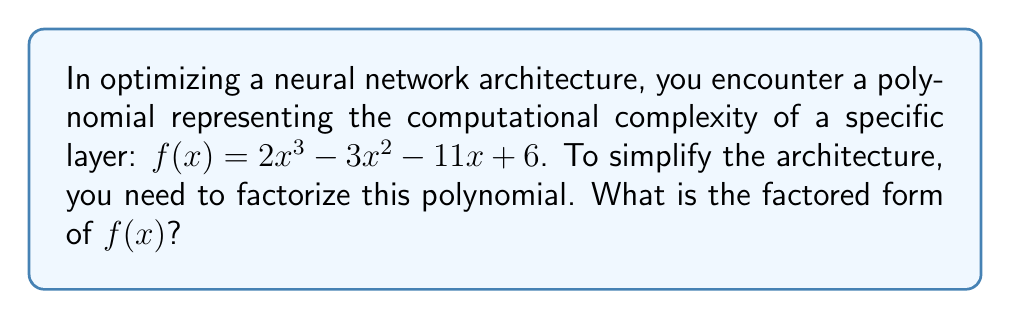Could you help me with this problem? To factorize this polynomial, we'll follow these steps:

1) First, let's check if there are any common factors. In this case, there are none.

2) Next, we'll use the rational root theorem to find potential roots. The potential rational roots are the factors of the constant term (6): ±1, ±2, ±3, ±6.

3) Let's test these potential roots:
   $f(1) = 2 - 3 - 11 + 6 = -6 \neq 0$
   $f(-1) = -2 - 3 + 11 + 6 = 12 \neq 0$
   $f(2) = 16 - 12 - 22 + 6 = -12 \neq 0$
   $f(-2) = -16 - 12 + 22 + 6 = 0$

4) We found that -2 is a root. So $(x+2)$ is a factor of $f(x)$.

5) We can divide $f(x)$ by $(x+2)$ to get the other factor:

   $$\frac{2x^3 - 3x^2 - 11x + 6}{x+2} = 2x^2 - 7x + 3$$

6) Now we need to factorize $2x^2 - 7x + 3$. Let's use the quadratic formula:
   
   $$x = \frac{7 \pm \sqrt{49 - 24}}{4} = \frac{7 \pm 5}{4}$$

7) This gives us two more roots: $x = 3$ and $x = \frac{1}{2}$

8) Therefore, the full factorization is:

   $$f(x) = (x+2)(2x-3)(x-\frac{1}{2})$$

9) To simplify further, we can write this as:

   $$f(x) = (x+2)(2x-3)(2x-1)$$

   $$f(x) = 2(x+2)(x-\frac{3}{2})(x-\frac{1}{2})$$
Answer: $2(x+2)(x-\frac{3}{2})(x-\frac{1}{2})$ 